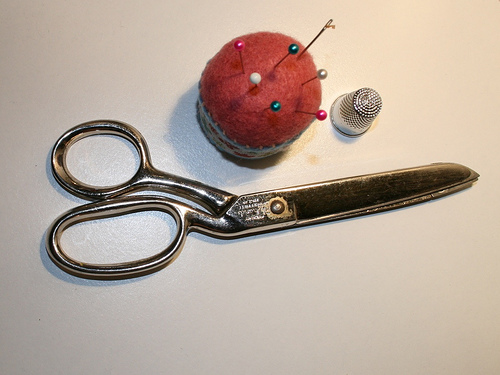<image>What animal is on the thimble? There is no animal on the thimble. What animal is on the thimble? There is no animal on the thimble. 